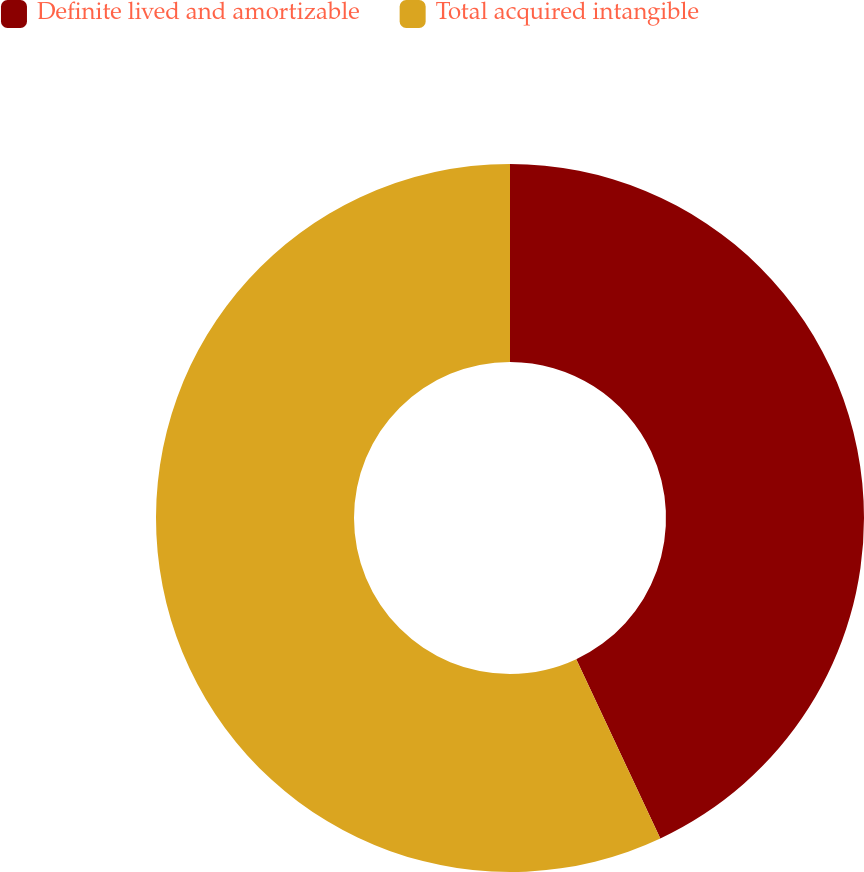Convert chart to OTSL. <chart><loc_0><loc_0><loc_500><loc_500><pie_chart><fcel>Definite lived and amortizable<fcel>Total acquired intangible<nl><fcel>43.02%<fcel>56.98%<nl></chart> 